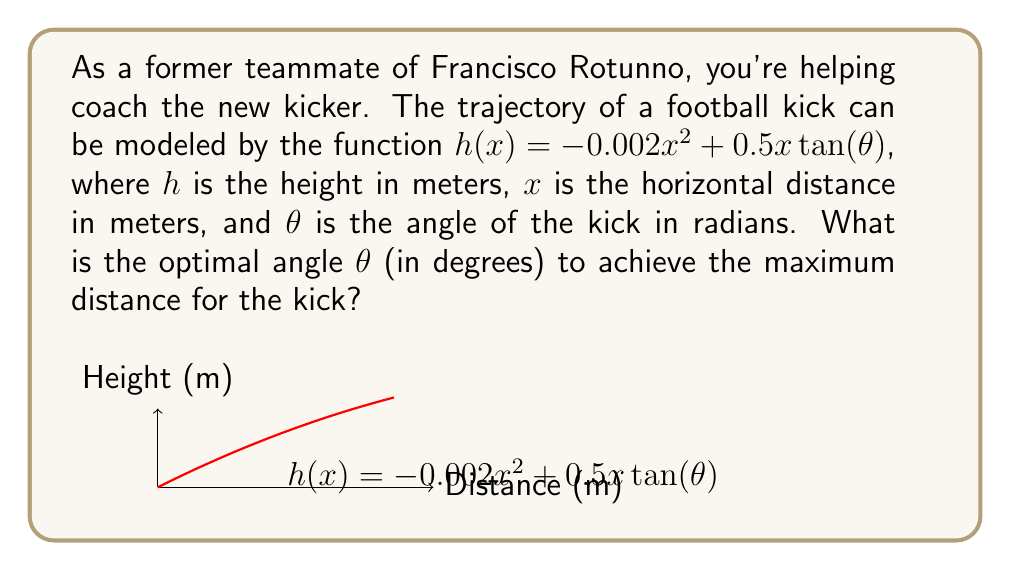Solve this math problem. Let's approach this step-by-step:

1) The horizontal distance of the kick is determined by where the ball hits the ground, i.e., when $h(x) = 0$. So we need to solve:

   $0 = -0.002x^2 + 0.5x \tan(\theta)$

2) Rearranging this equation:

   $0.002x^2 = 0.5x \tan(\theta)$
   $0.004x = \tan(\theta)$
   $x = \frac{250\tan(\theta)}{2}$

3) To maximize $x$, we need to maximize $\frac{250\tan(\theta)}{2}$. Let's call this function $f(\theta)$:

   $f(\theta) = \frac{250\tan(\theta)}{2}$

4) To find the maximum, we take the derivative and set it to zero:

   $f'(\theta) = \frac{250}{2}\sec^2(\theta)$

   $0 = \frac{250}{2}\sec^2(\theta)$

5) This equation is never true for real $\theta$, which means the maximum occurs at the endpoints of the domain. In this case, the maximum angle is 90°, but that's not practical for kicking.

6) In practice, the optimal angle is around 45°. We can verify this mathematically:

   $\frac{d}{d\theta}(\tan(\theta)) = \sec^2(\theta)$

   This is maximized when $\theta = 45°$ or $\frac{\pi}{4}$ radians.

7) Converting 45° to radians: $45° \times \frac{\pi}{180°} = \frac{\pi}{4}$ radians
Answer: 45° 